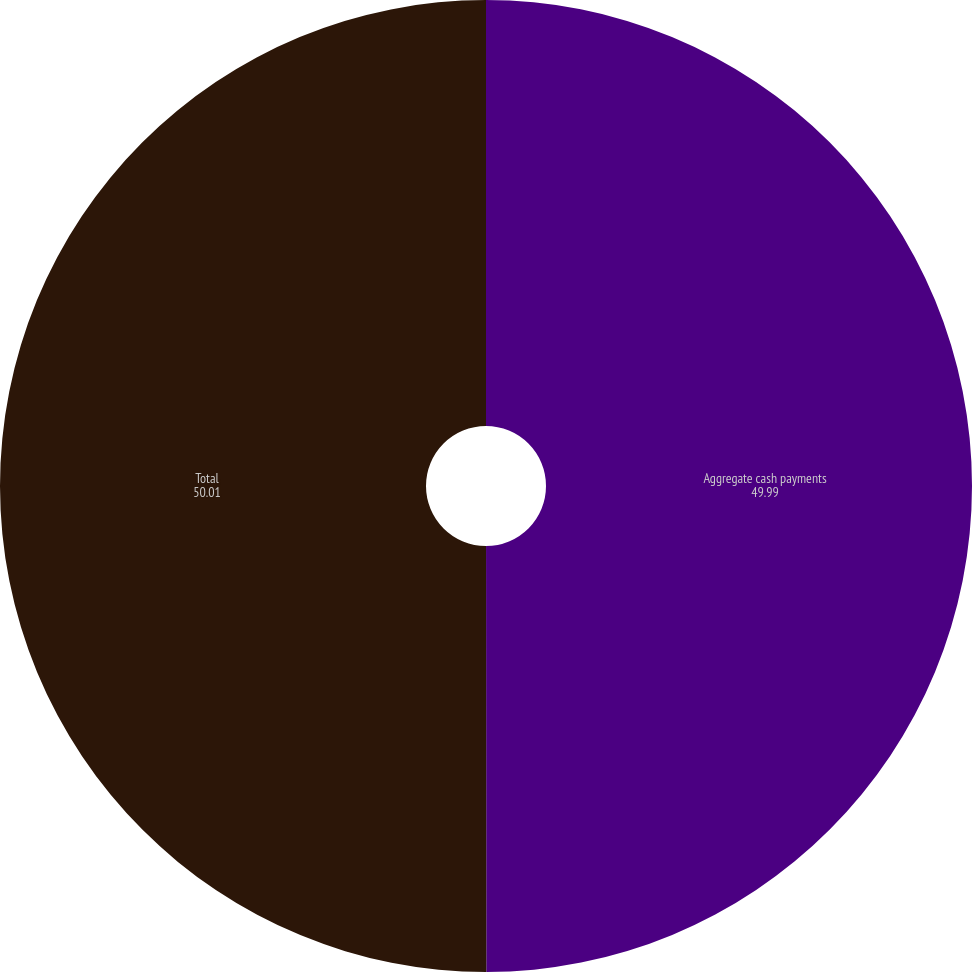Convert chart. <chart><loc_0><loc_0><loc_500><loc_500><pie_chart><fcel>Aggregate cash payments<fcel>Total<nl><fcel>49.99%<fcel>50.01%<nl></chart> 